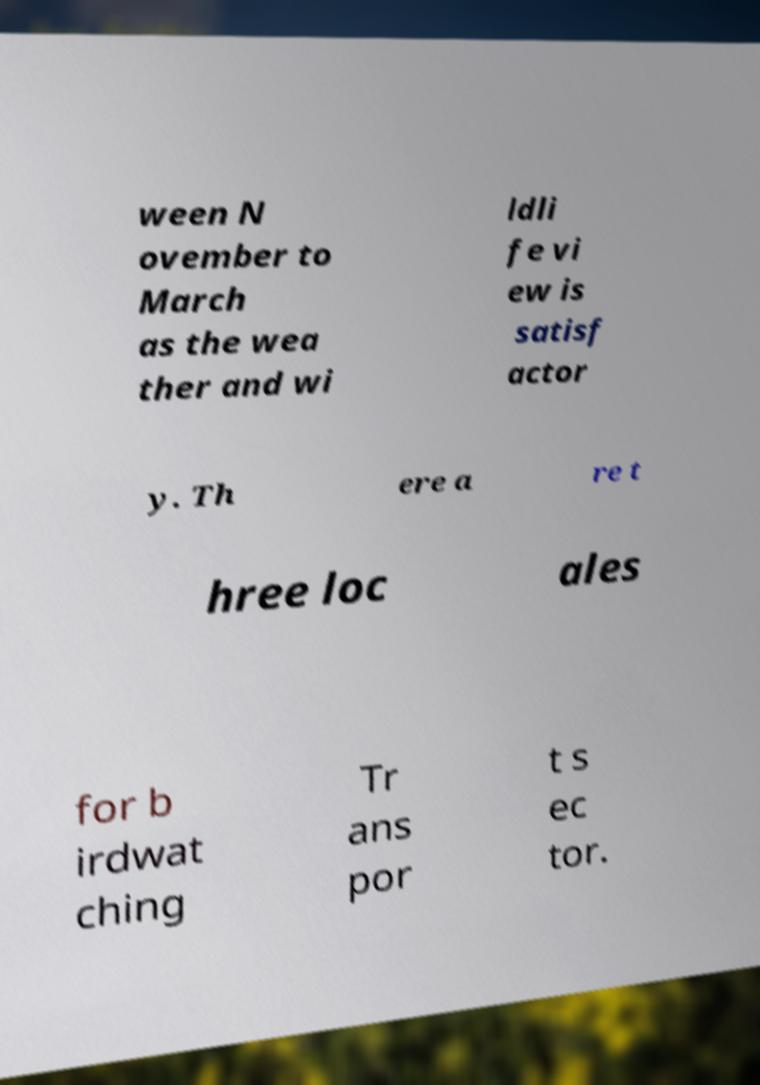There's text embedded in this image that I need extracted. Can you transcribe it verbatim? ween N ovember to March as the wea ther and wi ldli fe vi ew is satisf actor y. Th ere a re t hree loc ales for b irdwat ching Tr ans por t s ec tor. 